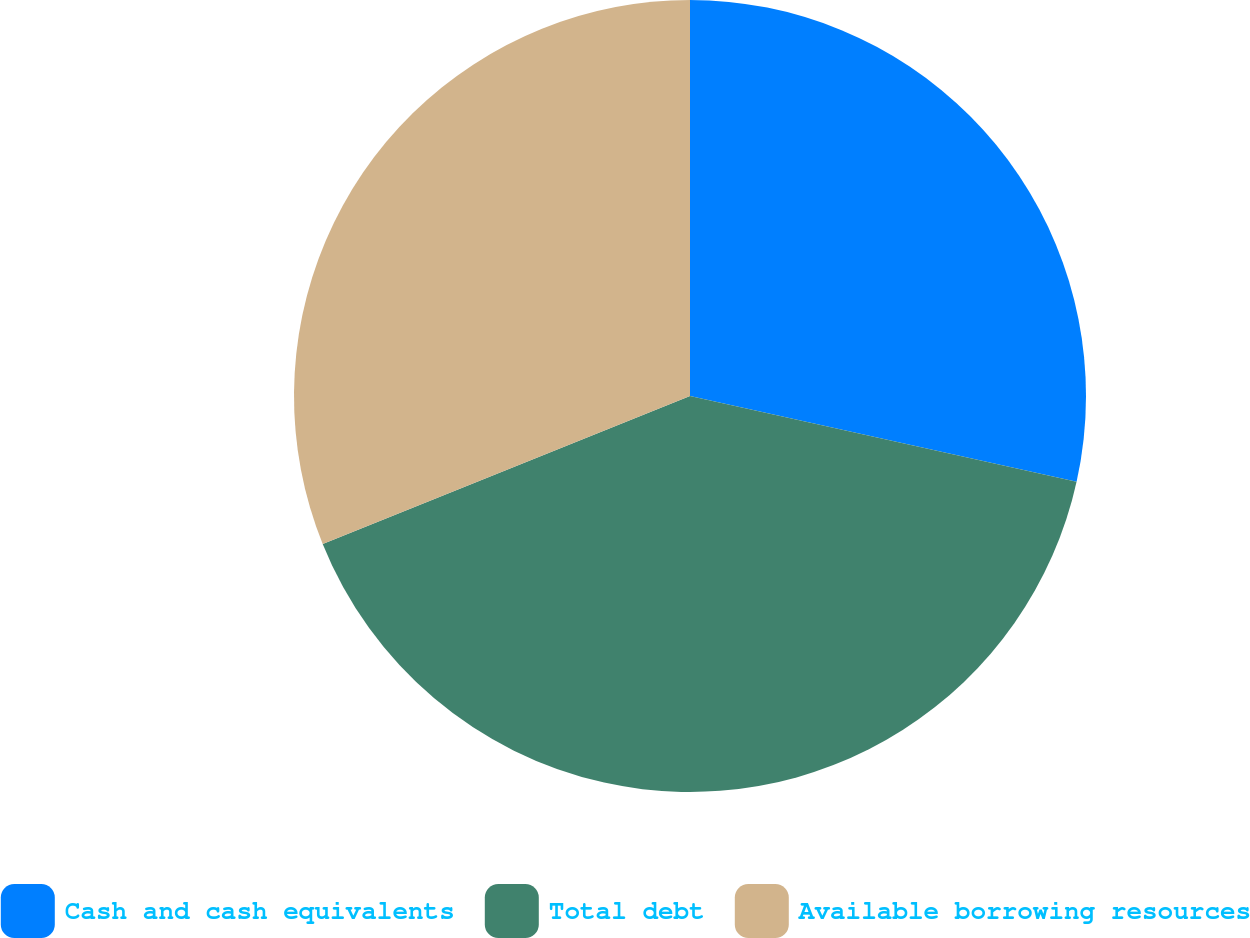Convert chart to OTSL. <chart><loc_0><loc_0><loc_500><loc_500><pie_chart><fcel>Cash and cash equivalents<fcel>Total debt<fcel>Available borrowing resources<nl><fcel>28.48%<fcel>40.43%<fcel>31.1%<nl></chart> 